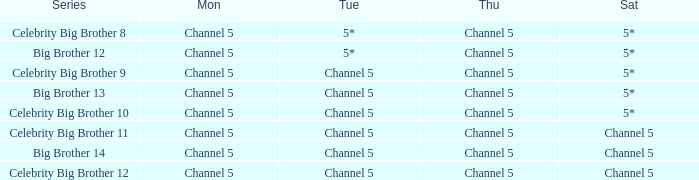Which series airs Saturday on Channel 5? Celebrity Big Brother 11, Big Brother 14, Celebrity Big Brother 12. 